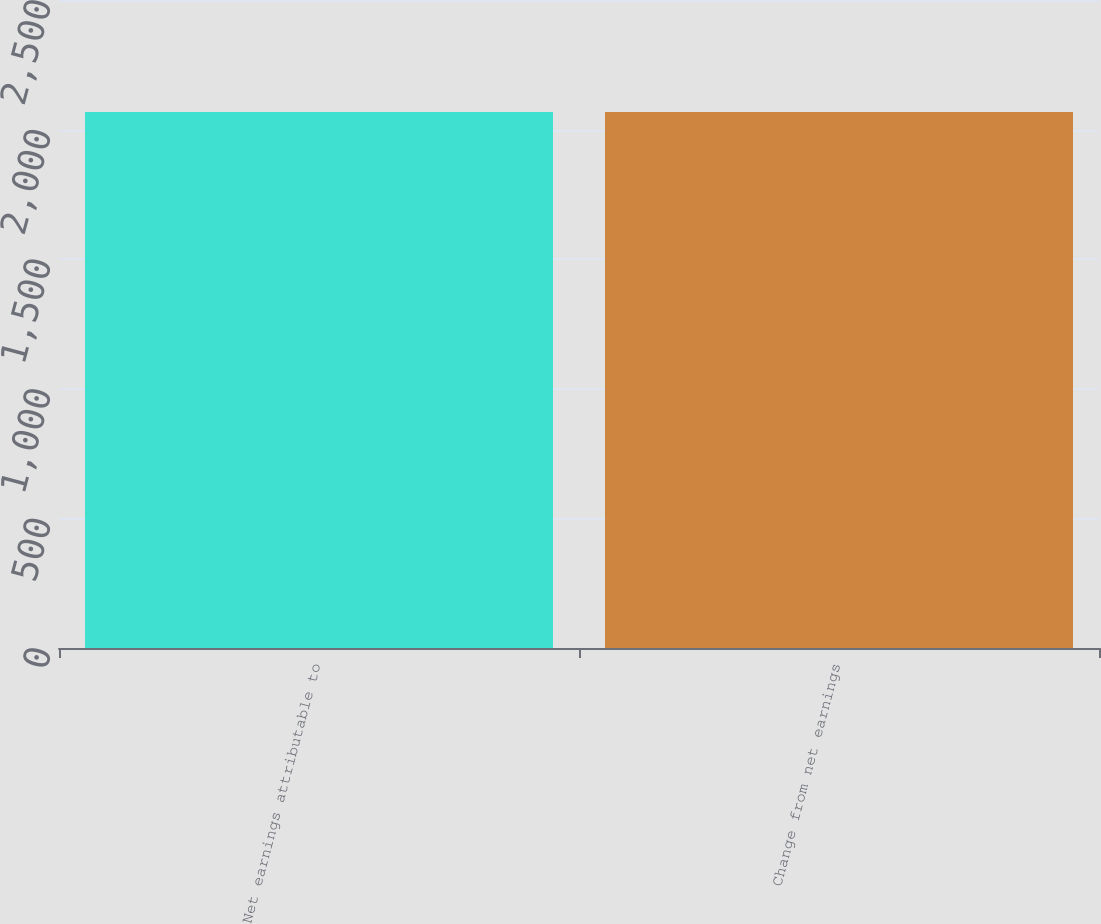<chart> <loc_0><loc_0><loc_500><loc_500><bar_chart><fcel>Net earnings attributable to<fcel>Change from net earnings<nl><fcel>2068.1<fcel>2068.2<nl></chart> 